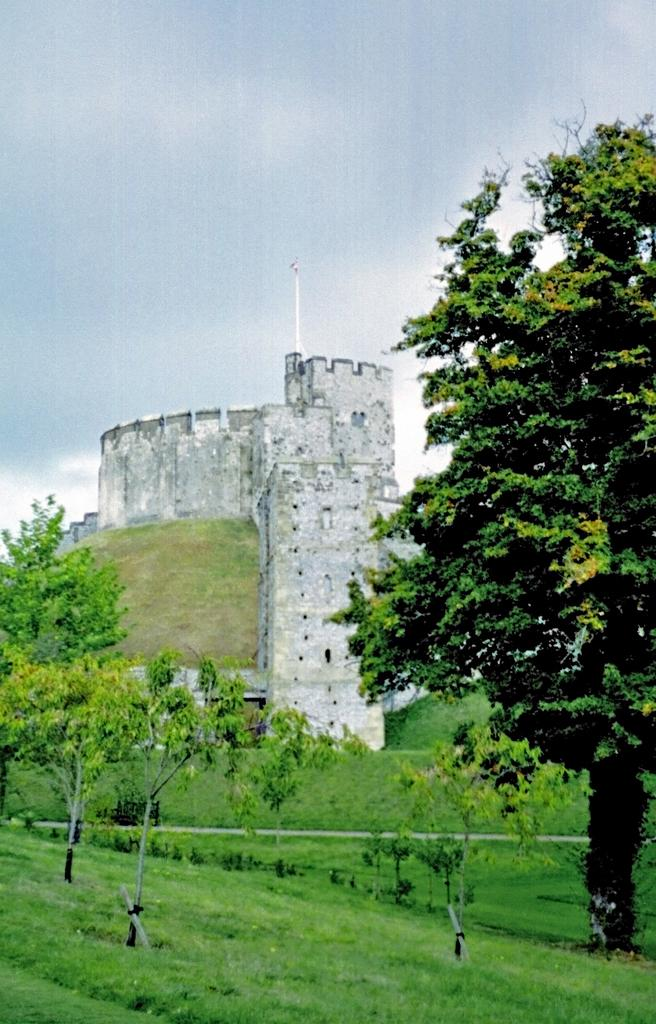What type of vegetation can be seen in the image? There are trees with branches and leaves in the image. What else can be seen on the ground in the image? There is grass visible in the image. What type of structure is present in the image? There appears to be a building in the image. What is visible above the trees and building in the image? The sky is visible in the image. Where is the table located in the image? There is no table present in the image. What type of picture is hanging on the wall in the image? There is no picture or wall present in the image. 